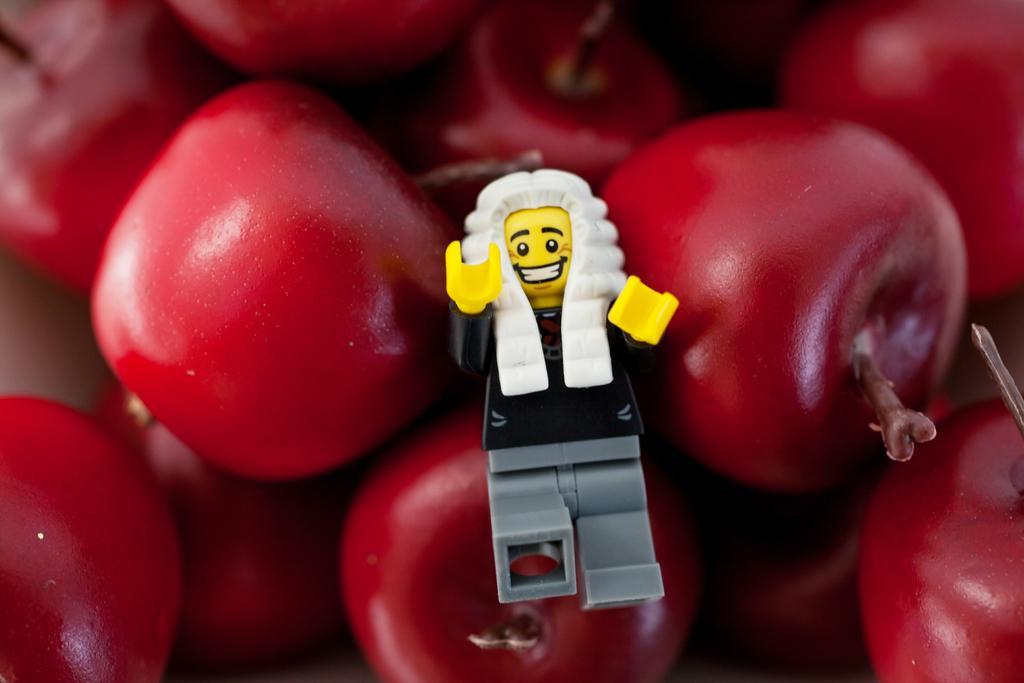Please provide a concise description of this image. In the foreground of this image, there is a toy on the red color fruits. 